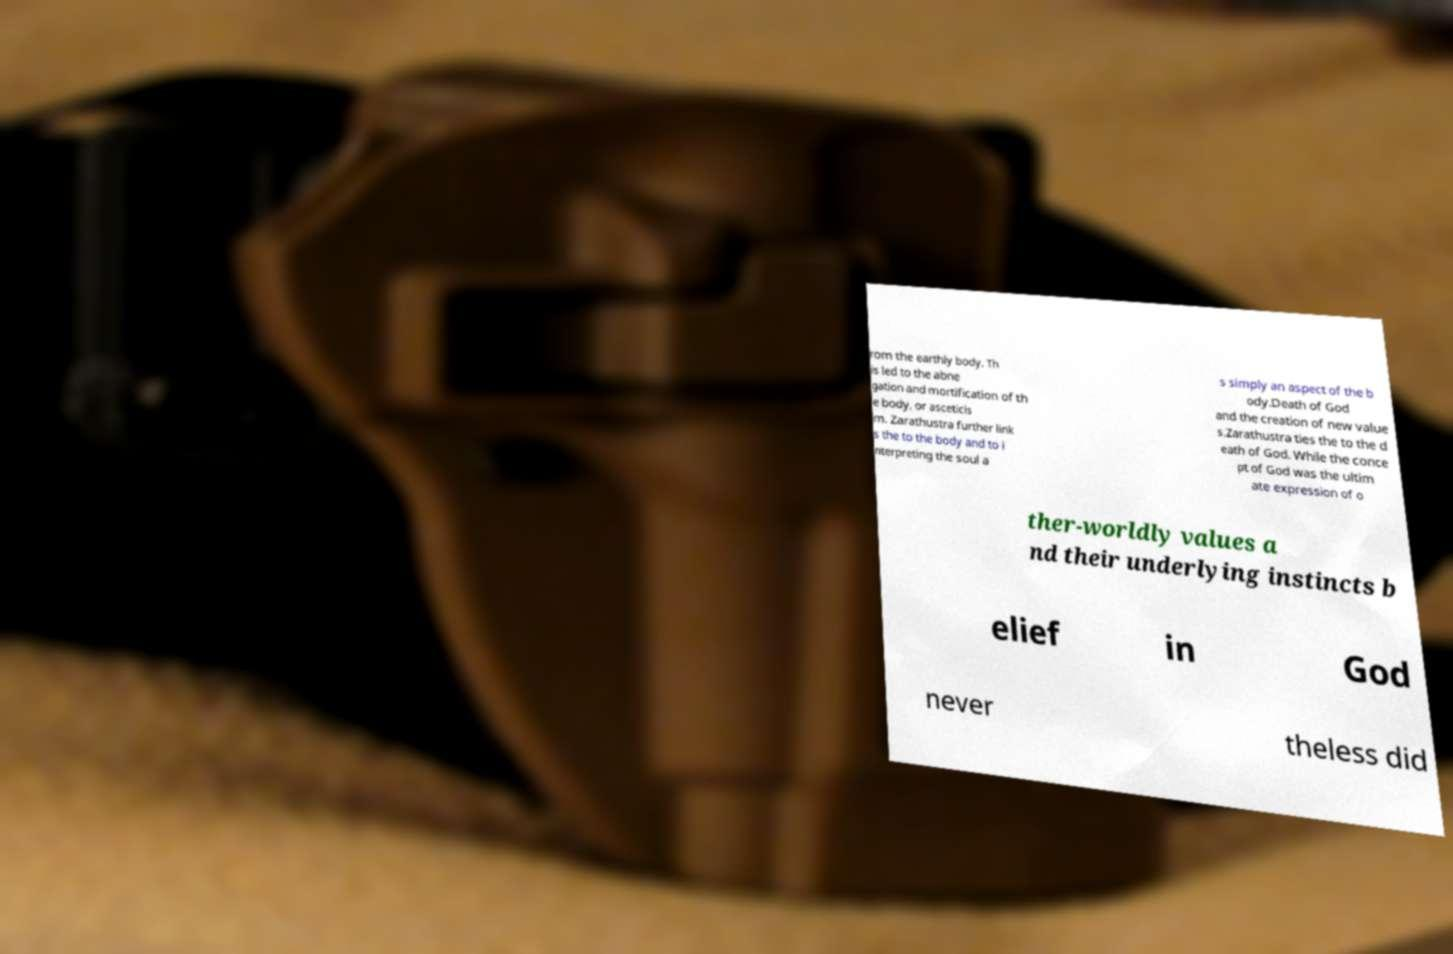What messages or text are displayed in this image? I need them in a readable, typed format. rom the earthly body. Th is led to the abne gation and mortification of th e body, or asceticis m. Zarathustra further link s the to the body and to i nterpreting the soul a s simply an aspect of the b ody.Death of God and the creation of new value s.Zarathustra ties the to the d eath of God. While the conce pt of God was the ultim ate expression of o ther-worldly values a nd their underlying instincts b elief in God never theless did 